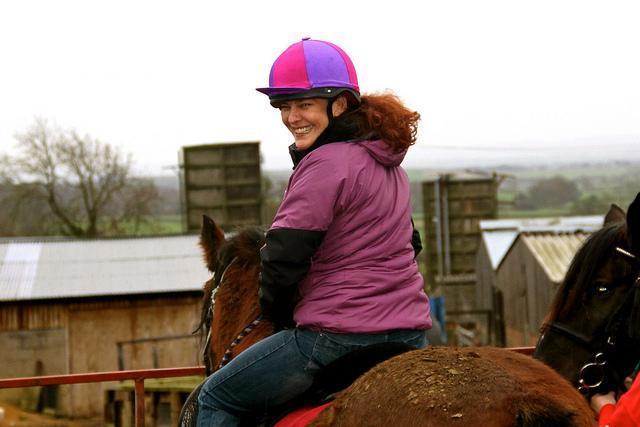How many horses are there?
Give a very brief answer. 2. 